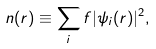<formula> <loc_0><loc_0><loc_500><loc_500>n ( r ) \equiv \sum _ { i } f | \psi _ { i } ( r ) | ^ { 2 } ,</formula> 